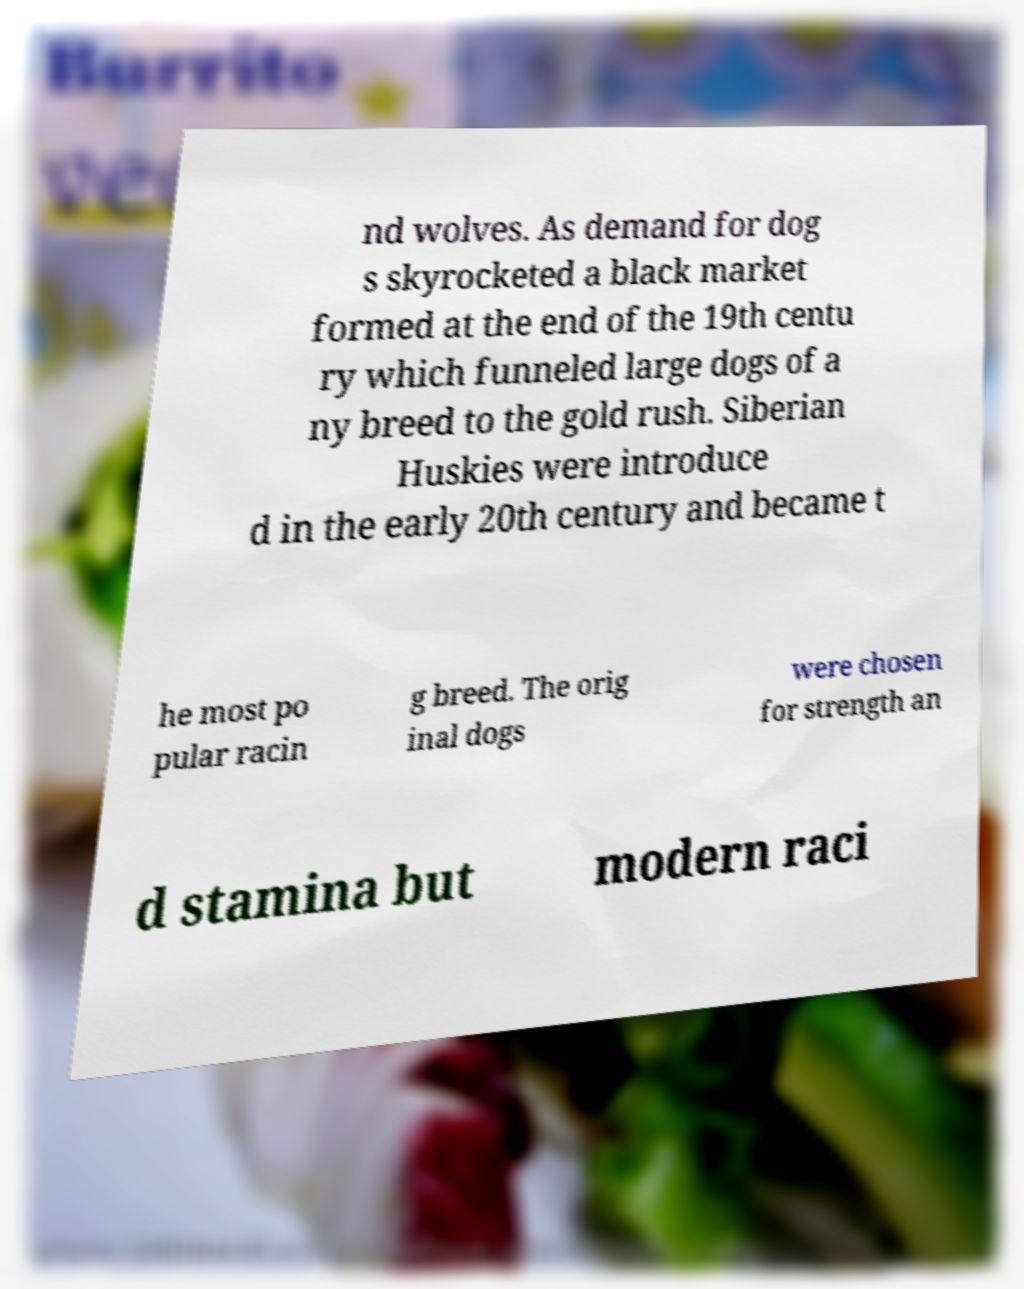Please read and relay the text visible in this image. What does it say? nd wolves. As demand for dog s skyrocketed a black market formed at the end of the 19th centu ry which funneled large dogs of a ny breed to the gold rush. Siberian Huskies were introduce d in the early 20th century and became t he most po pular racin g breed. The orig inal dogs were chosen for strength an d stamina but modern raci 